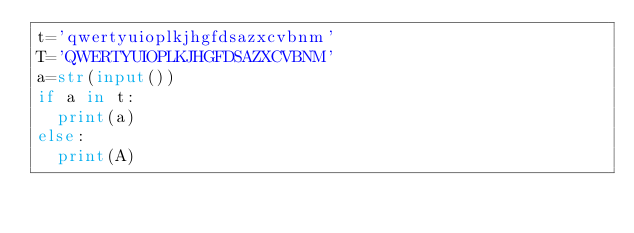<code> <loc_0><loc_0><loc_500><loc_500><_Python_>t='qwertyuioplkjhgfdsazxcvbnm'
T='QWERTYUIOPLKJHGFDSAZXCVBNM'
a=str(input())
if a in t:
  print(a)
else:
  print(A)
</code> 